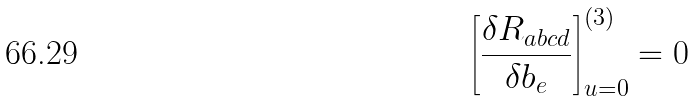Convert formula to latex. <formula><loc_0><loc_0><loc_500><loc_500>\left [ \frac { \delta R _ { a b c d } } { \delta b _ { e } } \right ] _ { u = 0 } ^ { ( 3 ) } = 0</formula> 